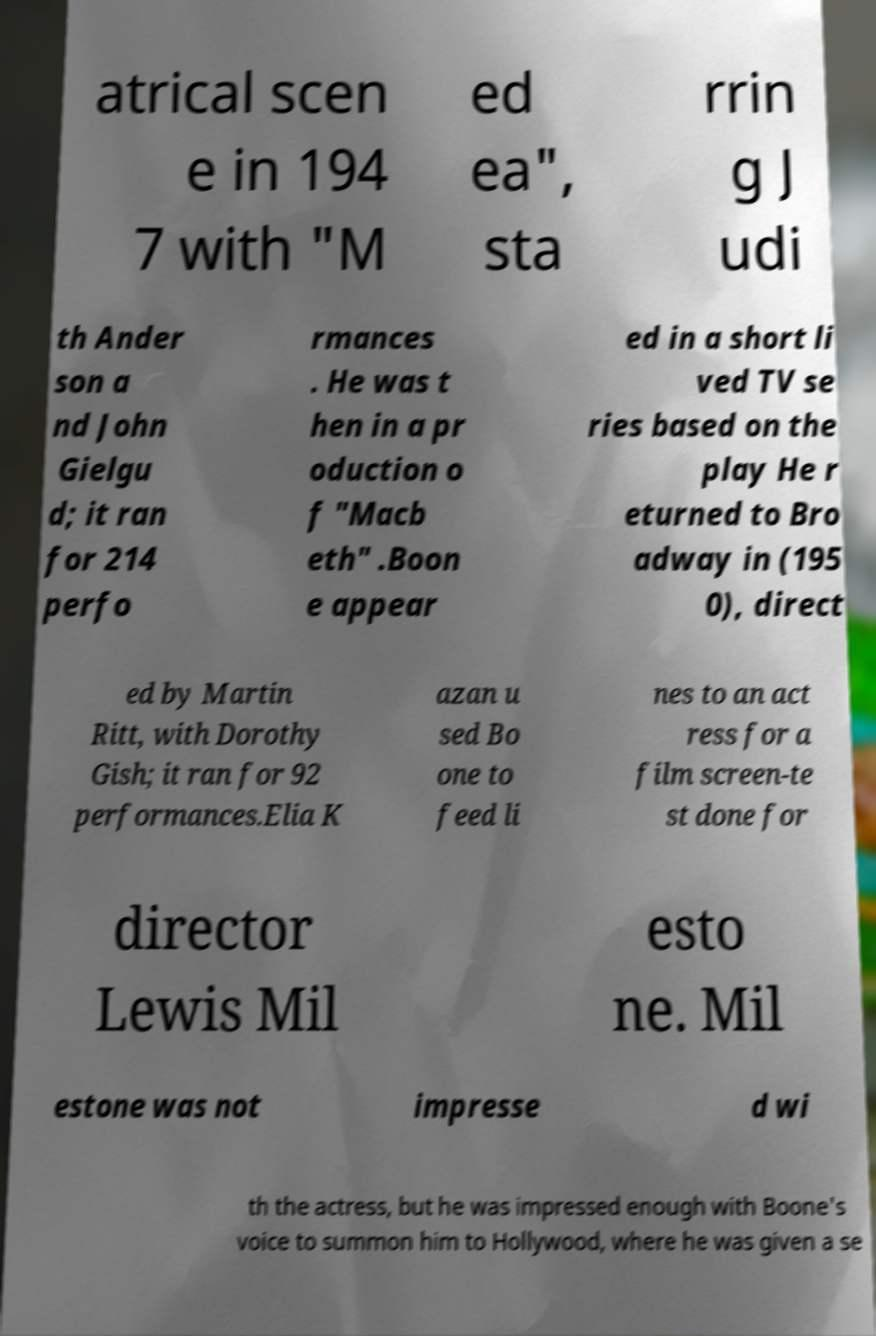Can you read and provide the text displayed in the image?This photo seems to have some interesting text. Can you extract and type it out for me? atrical scen e in 194 7 with "M ed ea", sta rrin g J udi th Ander son a nd John Gielgu d; it ran for 214 perfo rmances . He was t hen in a pr oduction o f "Macb eth" .Boon e appear ed in a short li ved TV se ries based on the play He r eturned to Bro adway in (195 0), direct ed by Martin Ritt, with Dorothy Gish; it ran for 92 performances.Elia K azan u sed Bo one to feed li nes to an act ress for a film screen-te st done for director Lewis Mil esto ne. Mil estone was not impresse d wi th the actress, but he was impressed enough with Boone's voice to summon him to Hollywood, where he was given a se 